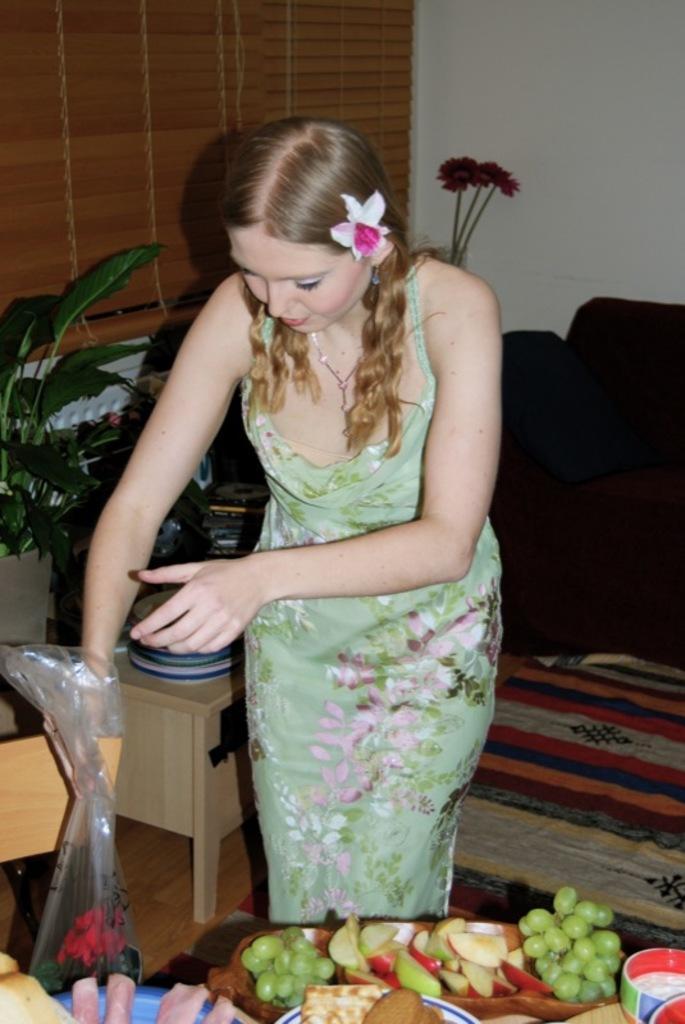In one or two sentences, can you explain what this image depicts? In this image, we can see a girl standing and there are some fruits in the plate, we can see a flower and there is a wall. 